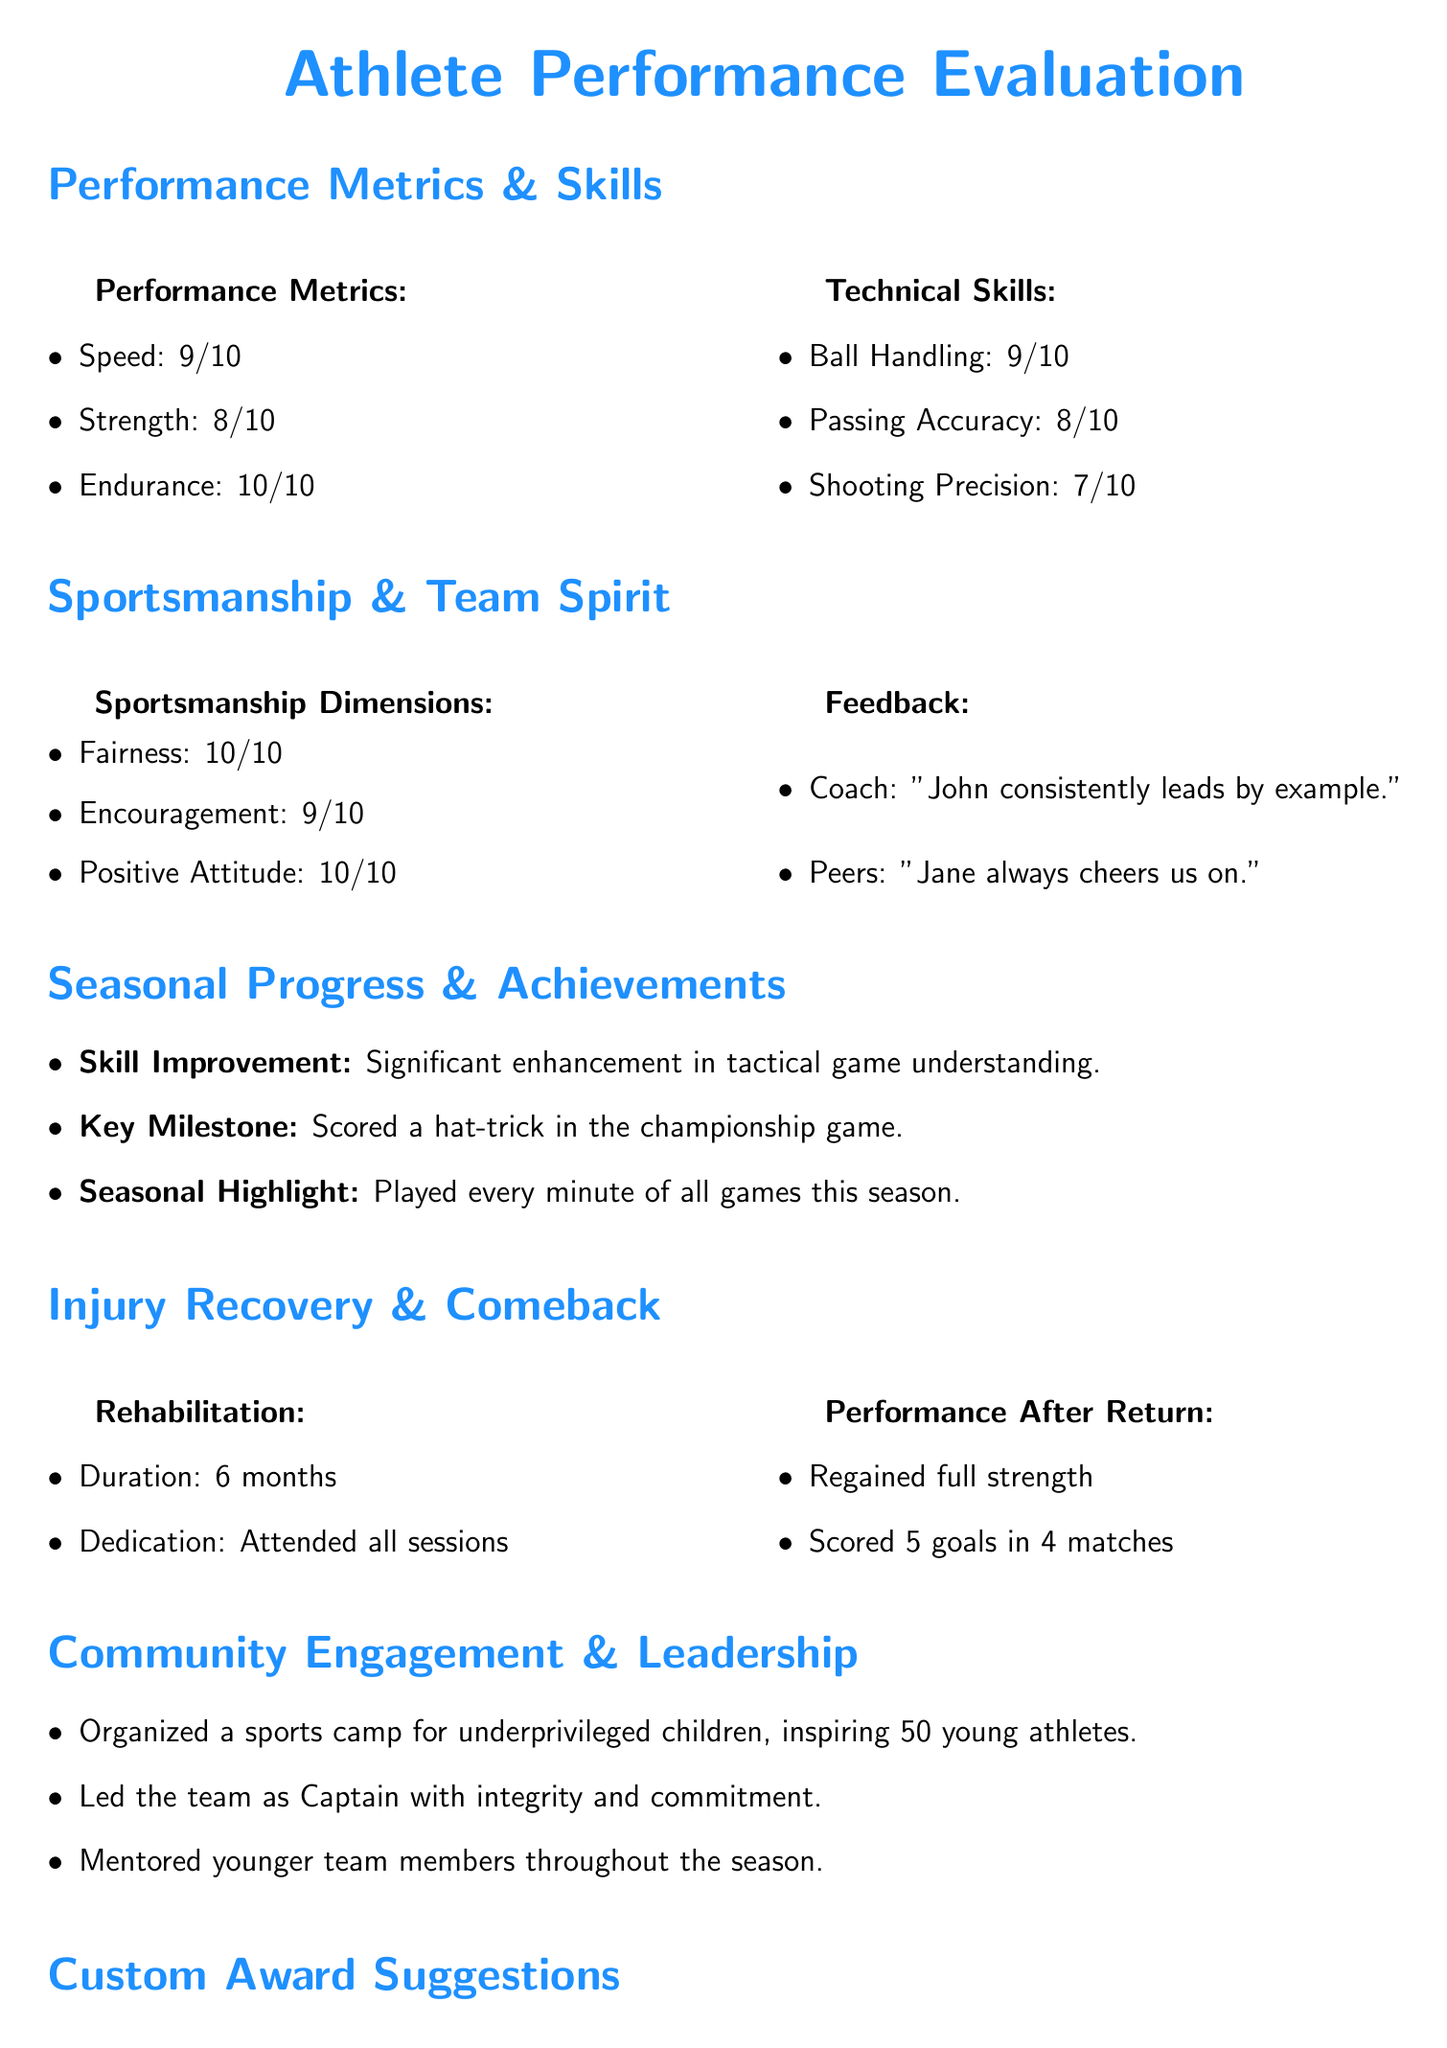What is the performance rating for endurance? The endurance rating is mentioned in the performance metrics section and it is rated 10/10.
Answer: 10/10 What is the key milestone achieved by the athlete? The key milestone is indicated in the seasonal progress section and states that the athlete scored a hat-trick in the championship game.
Answer: Hat-trick in the championship game What was the duration of the rehabilitation process? The rehabilitation duration is specified in the injury recovery section, stating it lasted for 6 months.
Answer: 6 months Who provided feedback highlighting encouragement among teammates? The peers provided feedback mentioning continuous encouragement, noted in the sportsmanship section.
Answer: Peers What is the proposed custom award for organizing the sports camp? The custom award suggested in the document specifically for organizing the sports camp is called the Community Leader Award.
Answer: Community Leader Award What was the total number of goals scored after returning from injury? The performance after returning from injury indicates that the athlete scored 5 goals in 4 matches.
Answer: 5 goals How did the athlete demonstrate sportsmanship according to their peers? The feedback from peers reflects the athlete's behavior, specifically commenting on their supportive attitude.
Answer: Supportive attitude What level of encouragement did the athlete receive for teamwork? The feedback section shows that the athlete received a rating of 9/10 for encouragement from teammates.
Answer: 9/10 